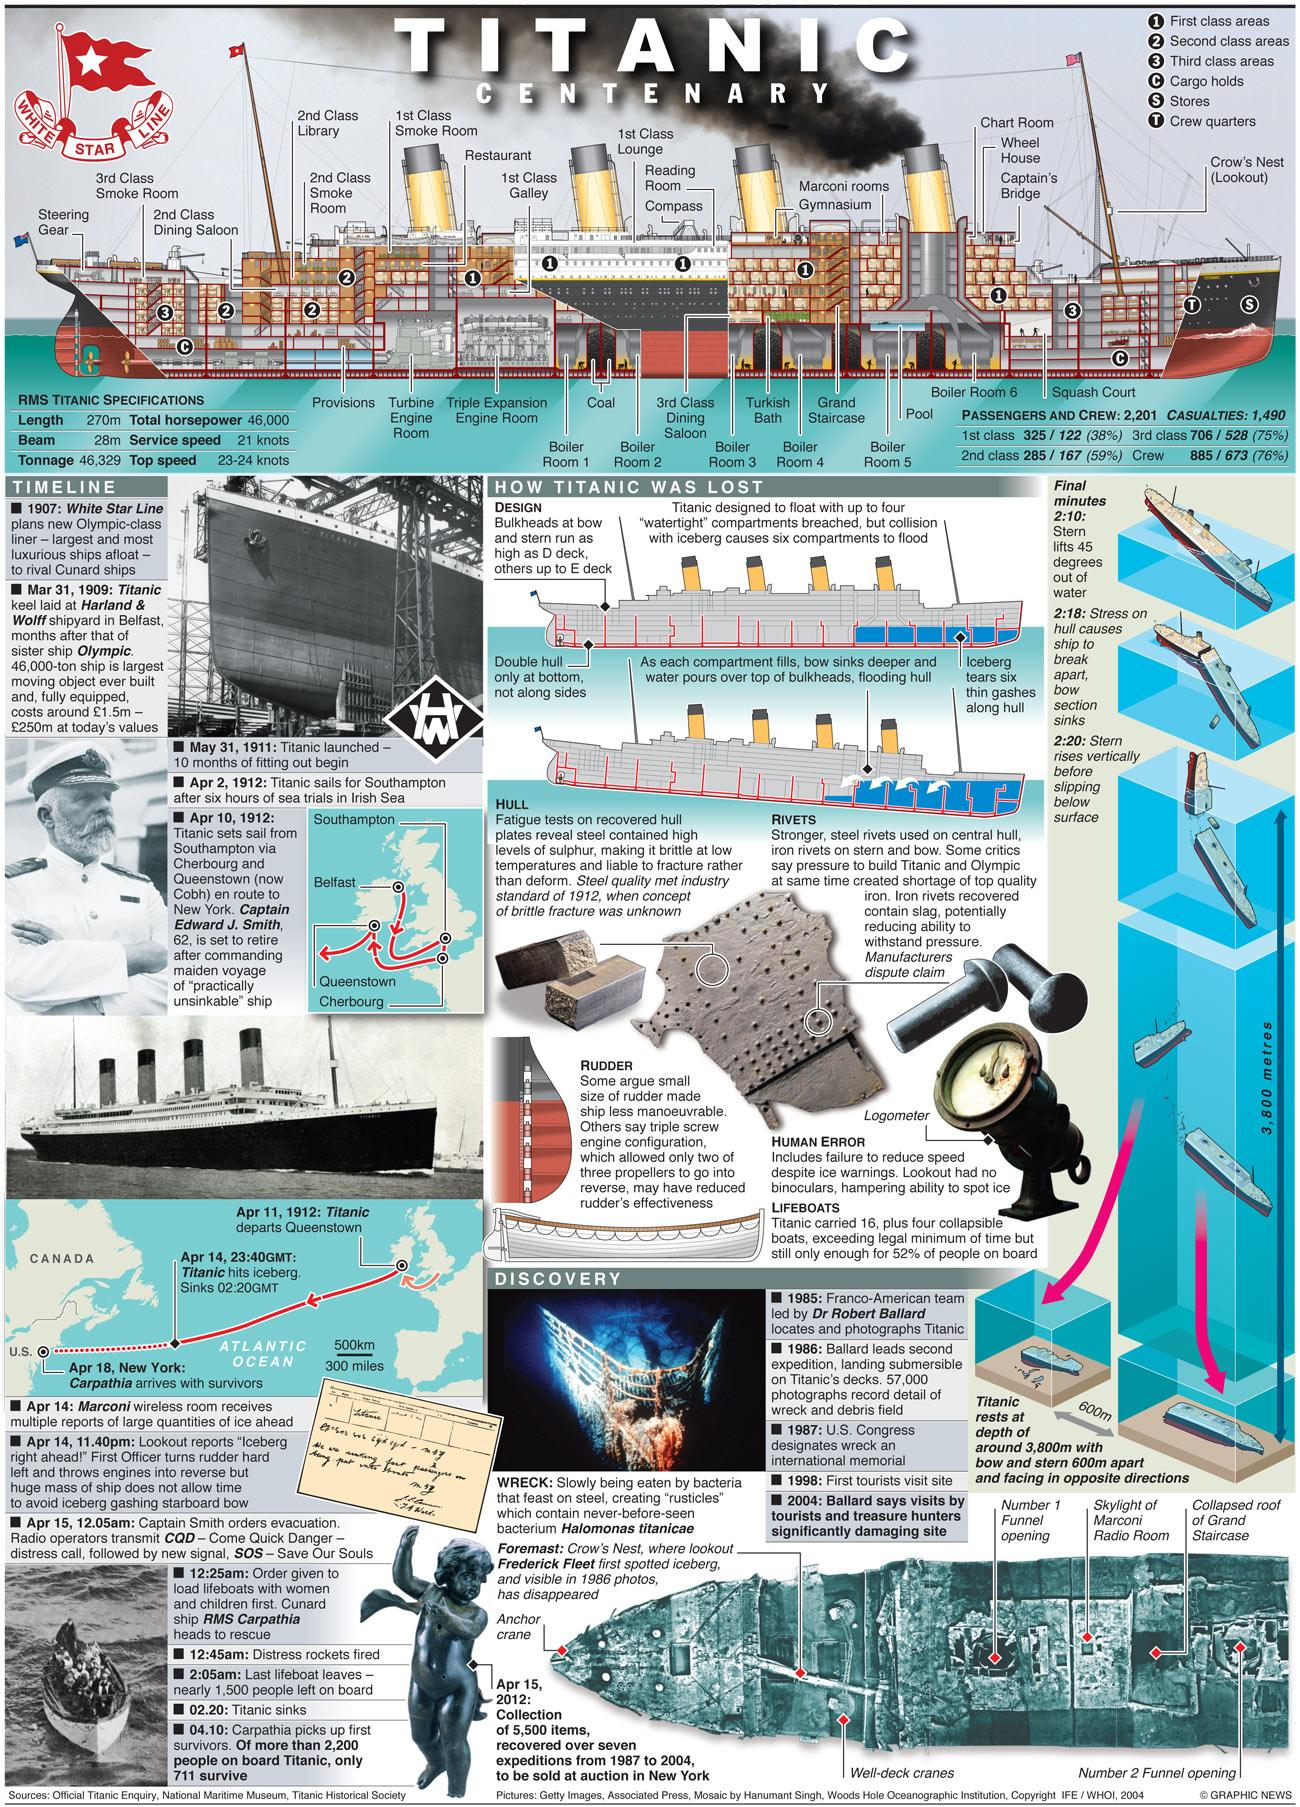Indicate a few pertinent items in this graphic. There are five first-class areas. There are a total of two cargo holds. There are three second class areas. All of the following are considered second class areas: Dining Saloon, Library, and Smoke Room. 